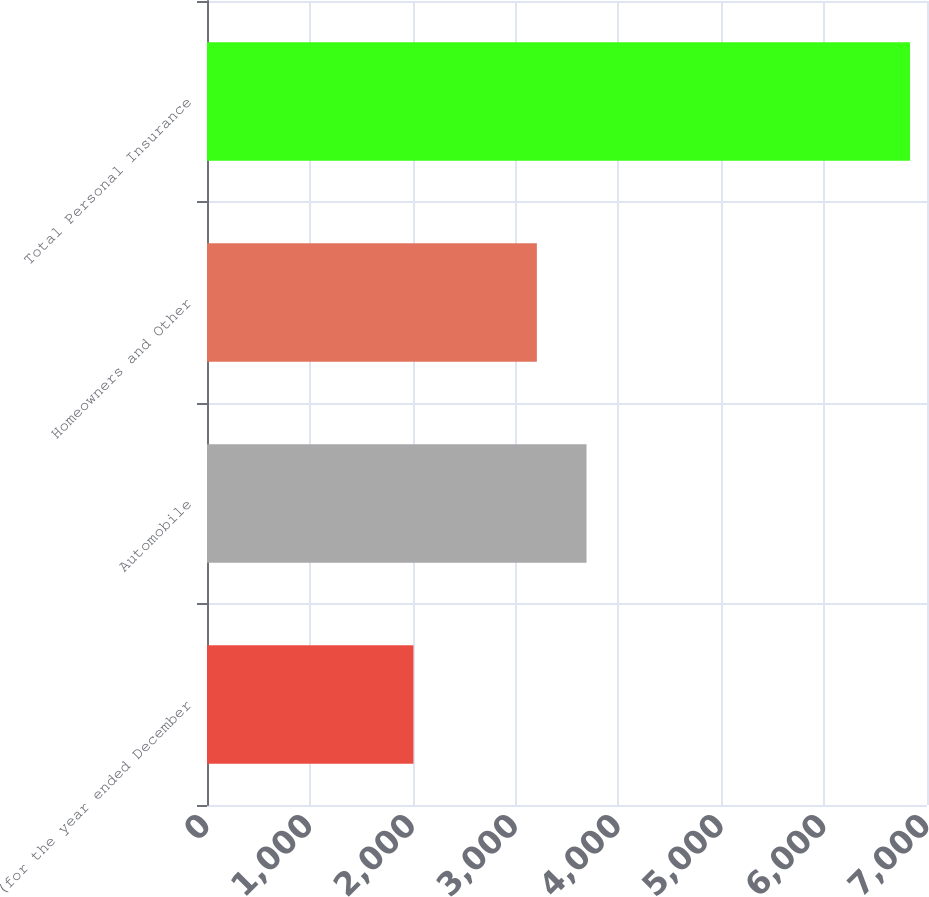Convert chart to OTSL. <chart><loc_0><loc_0><loc_500><loc_500><bar_chart><fcel>(for the year ended December<fcel>Automobile<fcel>Homeowners and Other<fcel>Total Personal Insurance<nl><fcel>2007<fcel>3689.8<fcel>3207<fcel>6835<nl></chart> 